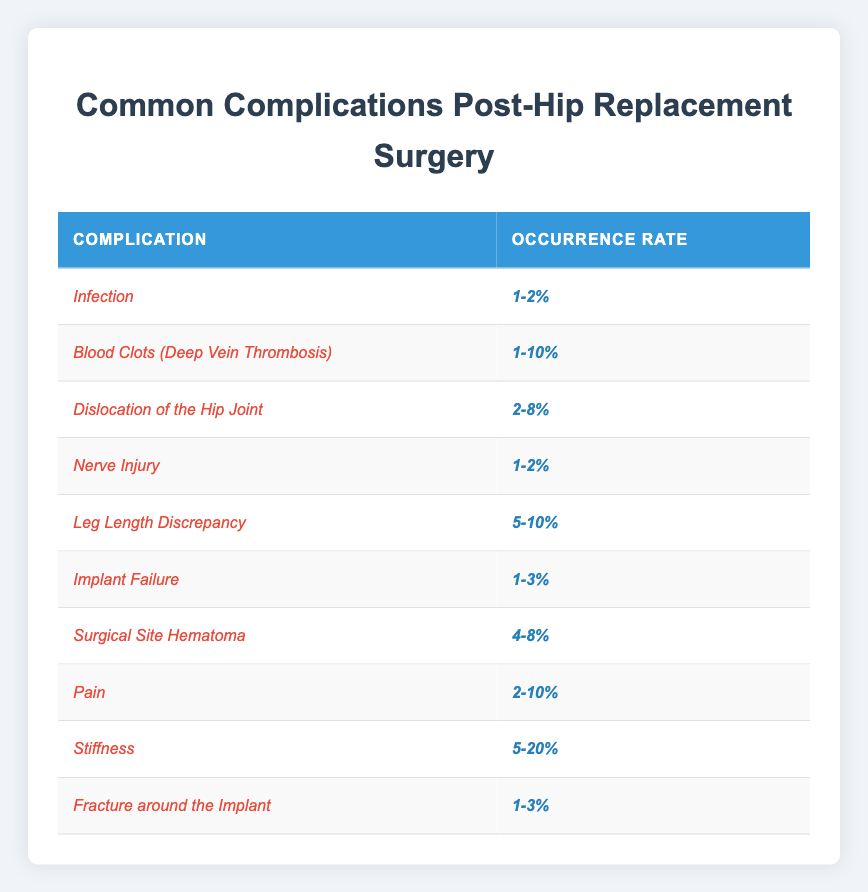What is the occurrence rate of infection after hip replacement surgery? The table lists the occurrence rate for infection, which is noted as 1-2%.
Answer: 1-2% Which complication has the highest possible occurrence rate? By comparing the ranges, stiffness has the highest occurrence rate ranging from 5-20%.
Answer: Stiffness (5-20%) Is the occurrence rate for nerve injury higher than that for implant failure? The occurrence rate for nerve injury is 1-2% while for implant failure it is 1-3%. Since 2% is higher than 1%, the statement is true.
Answer: Yes What is the average occurrence rate range for leg length discrepancy and surgical site hematoma? The ranges are 5-10% for leg length discrepancy and 4-8% for surgical site hematoma. The average lower end is (5+4)/2 = 4.5% and the average upper end is (10+8)/2 = 9%. So, the average rate range is 4.5-9%.
Answer: 4.5-9% If you are at risk for both blood clots and dislocation, what is the combined highest occurrence rate? The highest occurrence rate for blood clots is 10% and for dislocation is 8%. The combined highest occurrence rate is the maximum of these two, which is 10%.
Answer: 10% How many complications have an occurrence rate of less than 3%? The complications with occurrence rates of less than 3% are infection (1-2%), nerve injury (1-2%), implant failure (1-3%), and fracture around the implant (1-3%). This results in a total of 4 complications.
Answer: 4 Is there a complication that has the same occurrence rate range as another? Yes, both implant failure and fracture around the implant have occurrence rates of 1-3%.
Answer: Yes What is the difference between the highest and lowest occurrence rates for the complications provided? The highest occurrence rate is 20% (stiffness) and the lowest is 1% (infection, nerve injury, implant failure, and fracture). The difference is 20% - 1% = 19%.
Answer: 19% What percentage range does pain occur in after hip replacement surgery? The table indicates that pain has an occurrence rate ranging from 2-10%.
Answer: 2-10% Which complication is the least likely to occur, based on the occurrence rates provided in the table? The complications with the lowest occurrence rates, 1-2%, are infection and nerve injury. Therefore, these complications are the least likely to occur.
Answer: Infection and Nerve Injury 